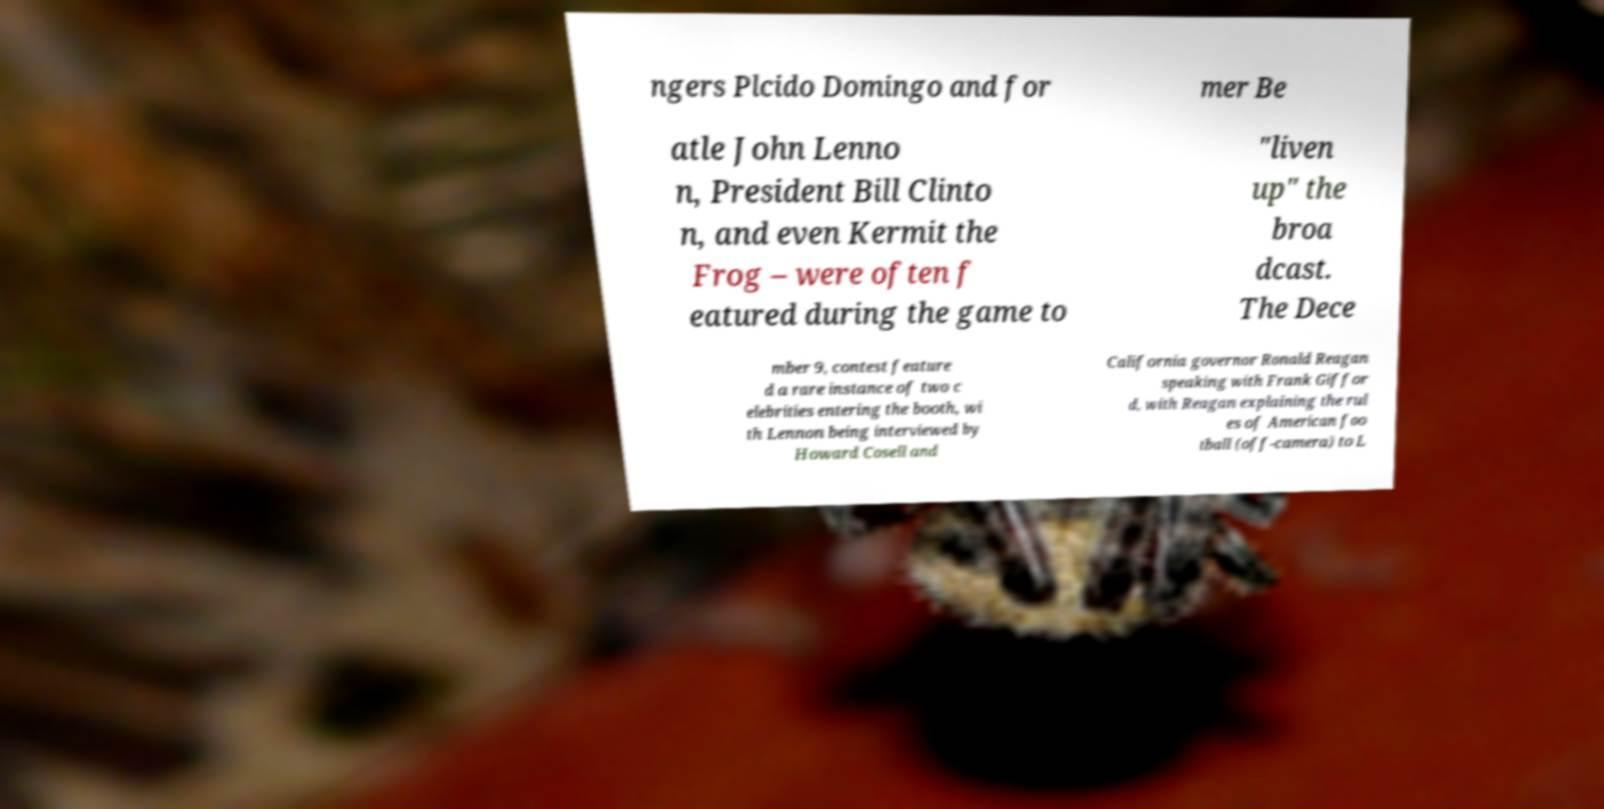What messages or text are displayed in this image? I need them in a readable, typed format. ngers Plcido Domingo and for mer Be atle John Lenno n, President Bill Clinto n, and even Kermit the Frog – were often f eatured during the game to "liven up" the broa dcast. The Dece mber 9, contest feature d a rare instance of two c elebrities entering the booth, wi th Lennon being interviewed by Howard Cosell and California governor Ronald Reagan speaking with Frank Giffor d, with Reagan explaining the rul es of American foo tball (off-camera) to L 